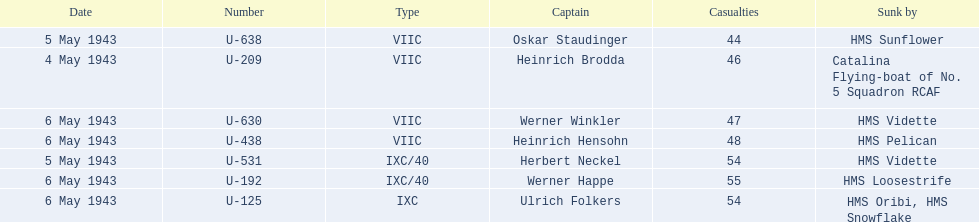Who are all of the captains? Heinrich Brodda, Oskar Staudinger, Herbert Neckel, Werner Happe, Ulrich Folkers, Werner Winkler, Heinrich Hensohn. What sunk each of the captains? Catalina Flying-boat of No. 5 Squadron RCAF, HMS Sunflower, HMS Vidette, HMS Loosestrife, HMS Oribi, HMS Snowflake, HMS Vidette, HMS Pelican. Which was sunk by the hms pelican? Heinrich Hensohn. 